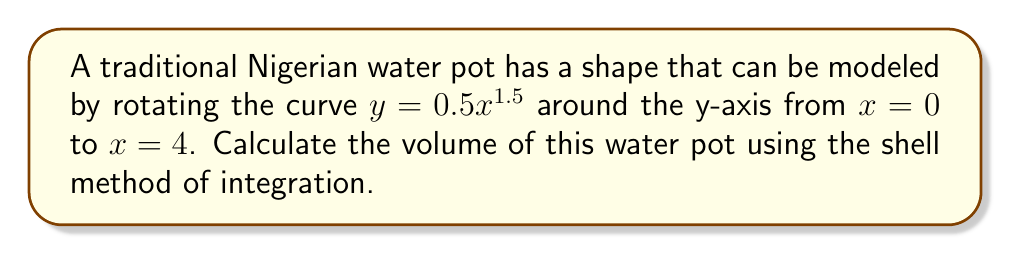Solve this math problem. To solve this problem, we'll use the shell method of integration. The steps are as follows:

1) The shell method formula for volume is:
   $$V = 2\pi \int_a^b x f(x) dx$$
   where $x$ is the radius of each shell and $f(x)$ is the height of each shell.

2) In this case, $f(x) = 0.5x^{1.5}$, $a = 0$, and $b = 4$.

3) Substituting these into our formula:
   $$V = 2\pi \int_0^4 x (0.5x^{1.5}) dx$$

4) Simplify inside the integral:
   $$V = \pi \int_0^4 x^{2.5} dx$$

5) Integrate:
   $$V = \pi \left[\frac{x^{3.5}}{3.5}\right]_0^4$$

6) Evaluate the integral:
   $$V = \pi \left(\frac{4^{3.5}}{3.5} - \frac{0^{3.5}}{3.5}\right)$$

7) Simplify:
   $$V = \pi \left(\frac{4^{3.5}}{3.5}\right) = \pi \left(\frac{32}{3.5}\right)$$

8) Calculate the final value:
   $$V \approx 28.65 \text{ cubic units}$$
Answer: $\frac{32\pi}{3.5} \approx 28.65 \text{ cubic units}$ 